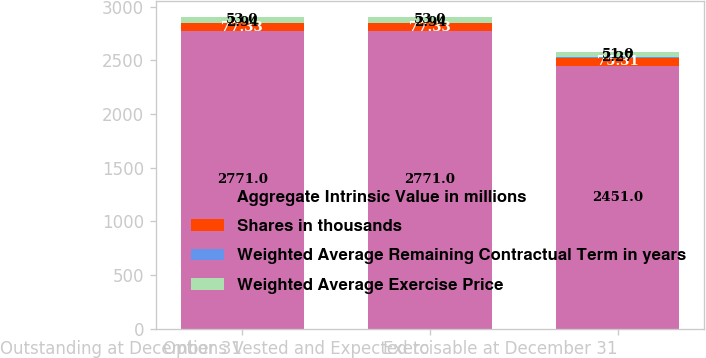<chart> <loc_0><loc_0><loc_500><loc_500><stacked_bar_chart><ecel><fcel>Outstanding at December 31<fcel>Options Vested and Expected to<fcel>Exercisable at December 31<nl><fcel>Aggregate Intrinsic Value in millions<fcel>2771<fcel>2771<fcel>2451<nl><fcel>Shares in thousands<fcel>77.33<fcel>77.33<fcel>75.31<nl><fcel>Weighted Average Remaining Contractual Term in years<fcel>2.94<fcel>2.94<fcel>2.27<nl><fcel>Weighted Average Exercise Price<fcel>53<fcel>53<fcel>51<nl></chart> 